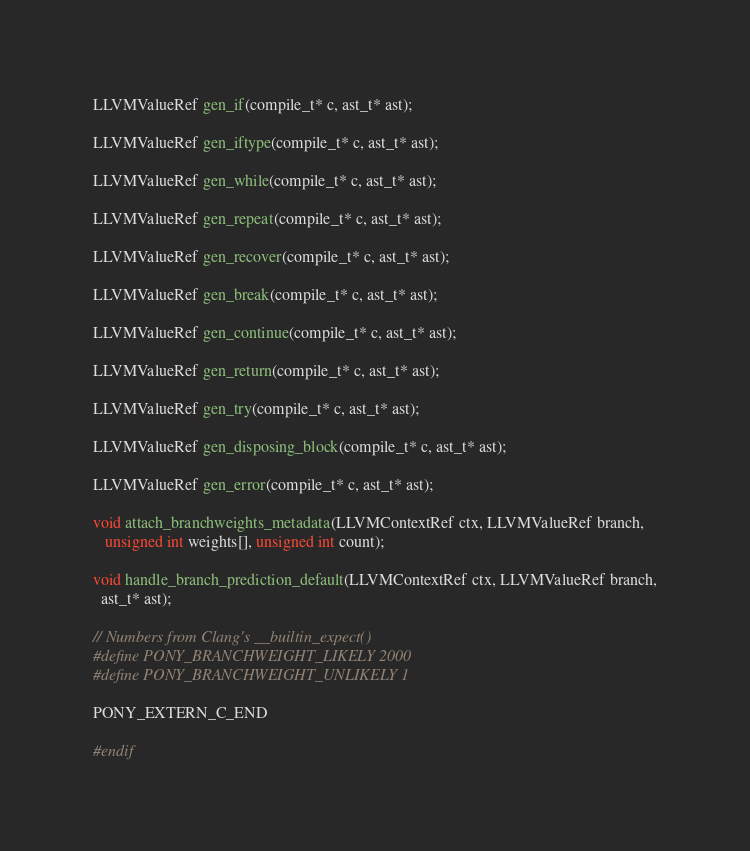Convert code to text. <code><loc_0><loc_0><loc_500><loc_500><_C_>
LLVMValueRef gen_if(compile_t* c, ast_t* ast);

LLVMValueRef gen_iftype(compile_t* c, ast_t* ast);

LLVMValueRef gen_while(compile_t* c, ast_t* ast);

LLVMValueRef gen_repeat(compile_t* c, ast_t* ast);

LLVMValueRef gen_recover(compile_t* c, ast_t* ast);

LLVMValueRef gen_break(compile_t* c, ast_t* ast);

LLVMValueRef gen_continue(compile_t* c, ast_t* ast);

LLVMValueRef gen_return(compile_t* c, ast_t* ast);

LLVMValueRef gen_try(compile_t* c, ast_t* ast);

LLVMValueRef gen_disposing_block(compile_t* c, ast_t* ast);

LLVMValueRef gen_error(compile_t* c, ast_t* ast);

void attach_branchweights_metadata(LLVMContextRef ctx, LLVMValueRef branch,
   unsigned int weights[], unsigned int count);

void handle_branch_prediction_default(LLVMContextRef ctx, LLVMValueRef branch,
  ast_t* ast);

// Numbers from Clang's __builtin_expect()
#define PONY_BRANCHWEIGHT_LIKELY 2000
#define PONY_BRANCHWEIGHT_UNLIKELY 1

PONY_EXTERN_C_END

#endif
</code> 